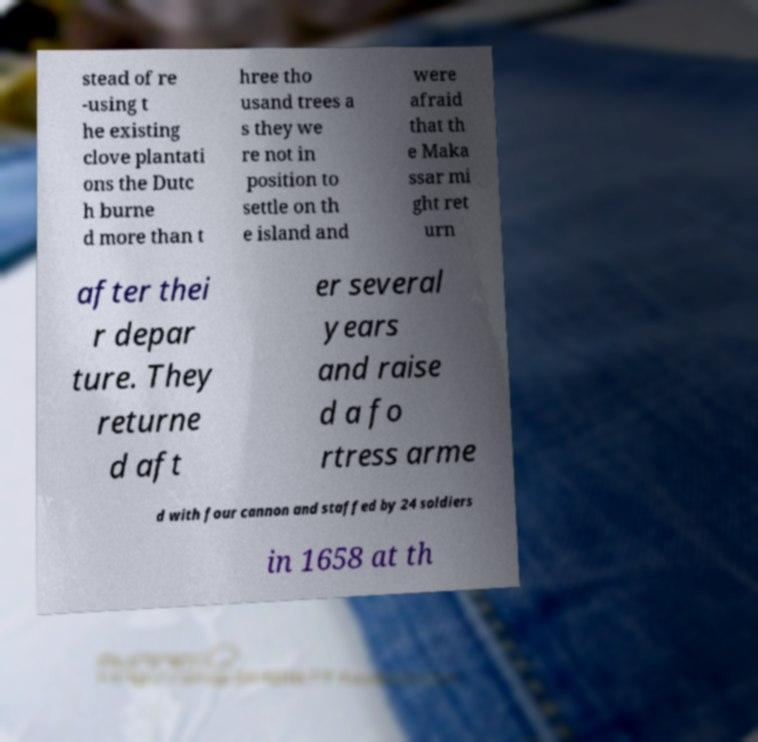Please read and relay the text visible in this image. What does it say? stead of re -using t he existing clove plantati ons the Dutc h burne d more than t hree tho usand trees a s they we re not in position to settle on th e island and were afraid that th e Maka ssar mi ght ret urn after thei r depar ture. They returne d aft er several years and raise d a fo rtress arme d with four cannon and staffed by 24 soldiers in 1658 at th 